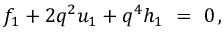Convert formula to latex. <formula><loc_0><loc_0><loc_500><loc_500>f _ { 1 } + 2 q ^ { 2 } u _ { 1 } + q ^ { 4 } h _ { 1 } \ = \ 0 \, ,</formula> 